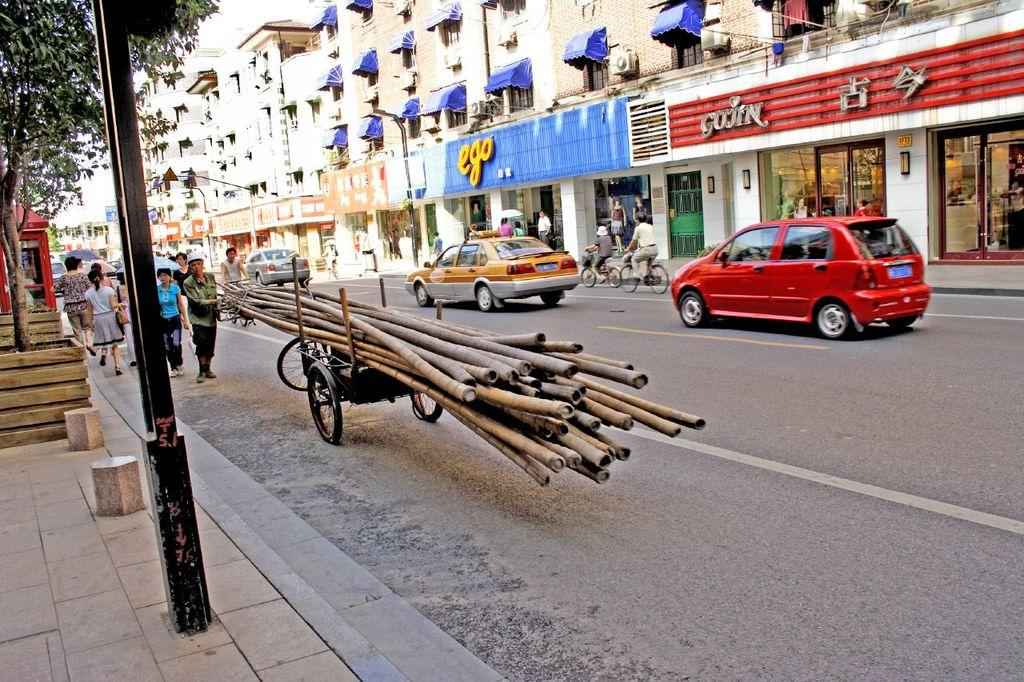<image>
Describe the image concisely. A car is driving in front of a store called ego. 